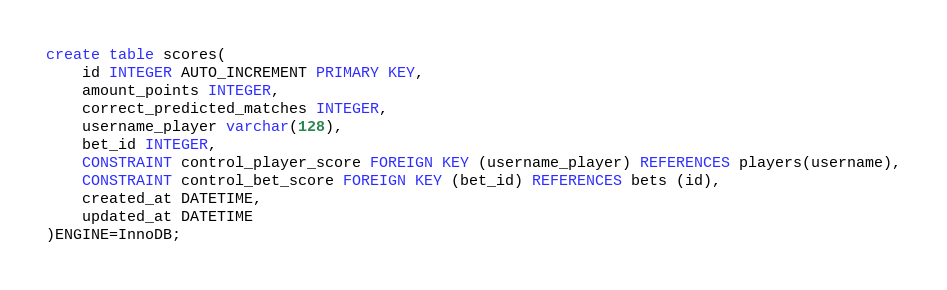<code> <loc_0><loc_0><loc_500><loc_500><_SQL_>create table scores(  
	id INTEGER AUTO_INCREMENT PRIMARY KEY,
    amount_points INTEGER,
	correct_predicted_matches INTEGER,
	username_player varchar(128),
	bet_id INTEGER,
	CONSTRAINT control_player_score FOREIGN KEY (username_player) REFERENCES players(username),
	CONSTRAINT control_bet_score FOREIGN KEY (bet_id) REFERENCES bets (id),
  	created_at DATETIME,
  	updated_at DATETIME
)ENGINE=InnoDB;
</code> 